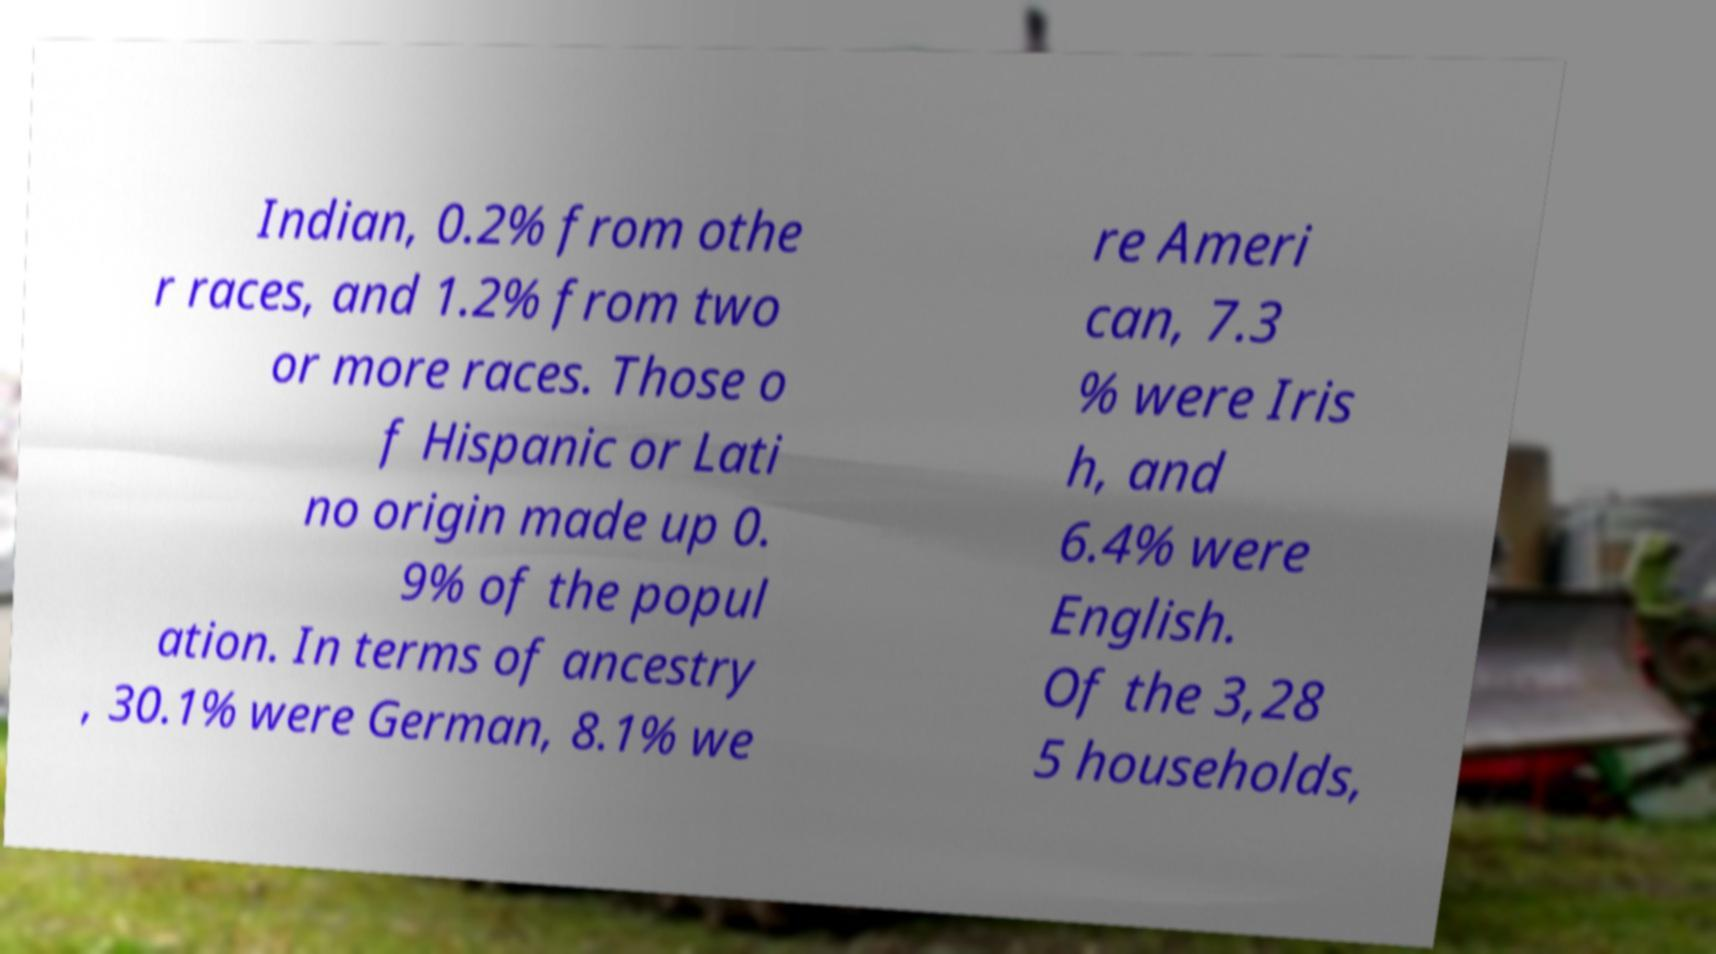Could you assist in decoding the text presented in this image and type it out clearly? Indian, 0.2% from othe r races, and 1.2% from two or more races. Those o f Hispanic or Lati no origin made up 0. 9% of the popul ation. In terms of ancestry , 30.1% were German, 8.1% we re Ameri can, 7.3 % were Iris h, and 6.4% were English. Of the 3,28 5 households, 